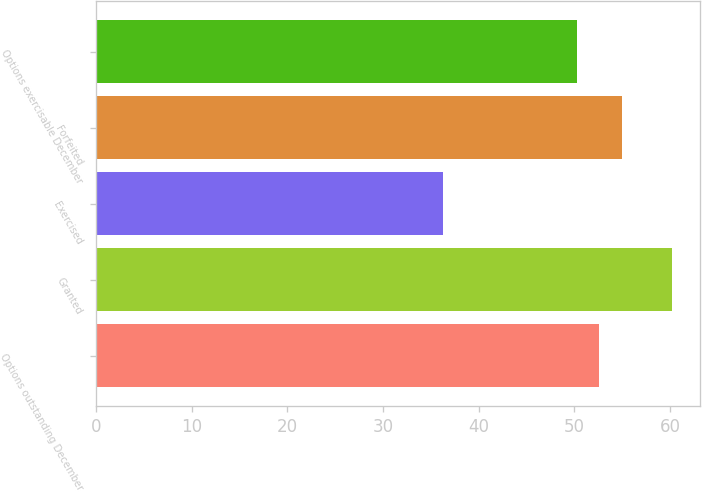Convert chart to OTSL. <chart><loc_0><loc_0><loc_500><loc_500><bar_chart><fcel>Options outstanding December<fcel>Granted<fcel>Exercised<fcel>Forfeited<fcel>Options exercisable December<nl><fcel>52.63<fcel>60.17<fcel>36.25<fcel>55.02<fcel>50.24<nl></chart> 